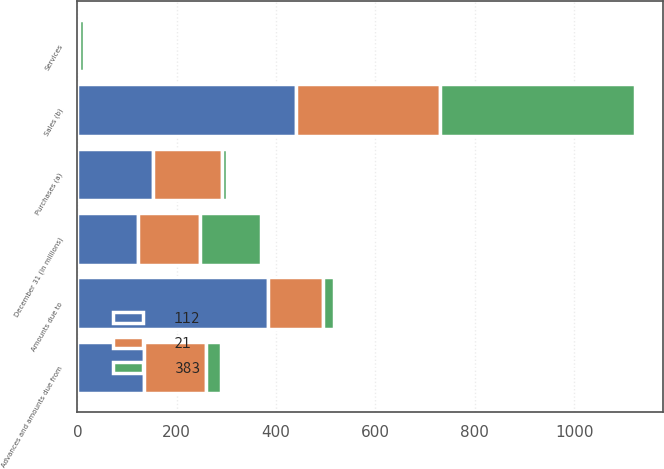<chart> <loc_0><loc_0><loc_500><loc_500><stacked_bar_chart><ecel><fcel>December 31 (in millions)<fcel>Purchases (a)<fcel>Sales (b)<fcel>Services<fcel>Advances and amounts due from<fcel>Amounts due to<nl><fcel>383<fcel>123<fcel>10<fcel>392<fcel>10<fcel>32<fcel>21<nl><fcel>112<fcel>123<fcel>153<fcel>440<fcel>2<fcel>135<fcel>383<nl><fcel>21<fcel>123<fcel>138<fcel>291<fcel>2<fcel>123<fcel>112<nl></chart> 